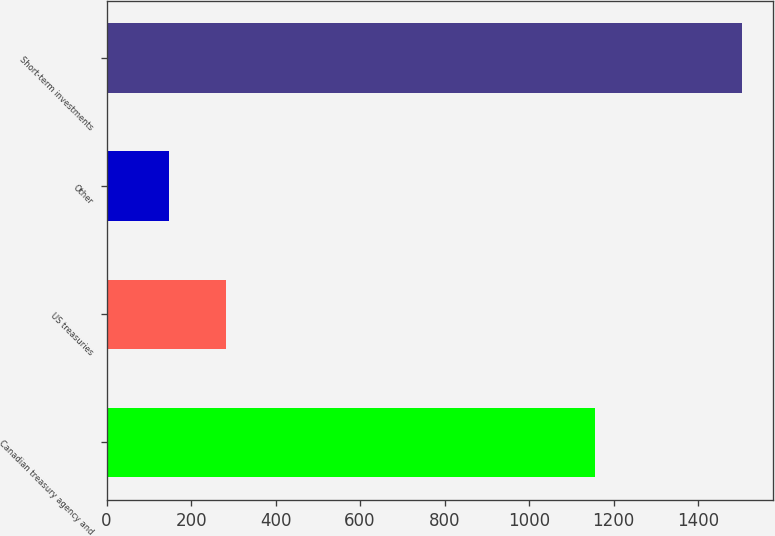<chart> <loc_0><loc_0><loc_500><loc_500><bar_chart><fcel>Canadian treasury agency and<fcel>US treasuries<fcel>Other<fcel>Short-term investments<nl><fcel>1155<fcel>282.6<fcel>147<fcel>1503<nl></chart> 